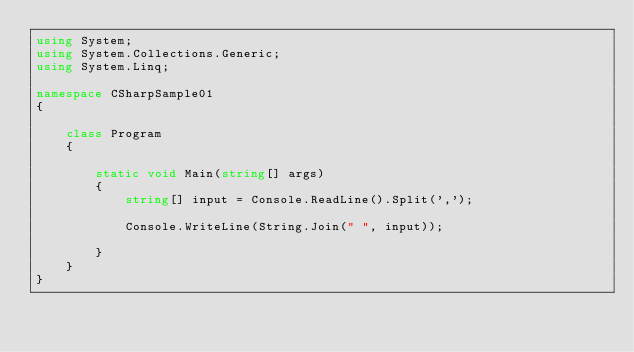<code> <loc_0><loc_0><loc_500><loc_500><_C#_>using System;
using System.Collections.Generic;
using System.Linq;

namespace CSharpSample01
{
    
    class Program
    {
        
        static void Main(string[] args)
        {
            string[] input = Console.ReadLine().Split(',');

            Console.WriteLine(String.Join(" ", input));

        }
    }
}
</code> 